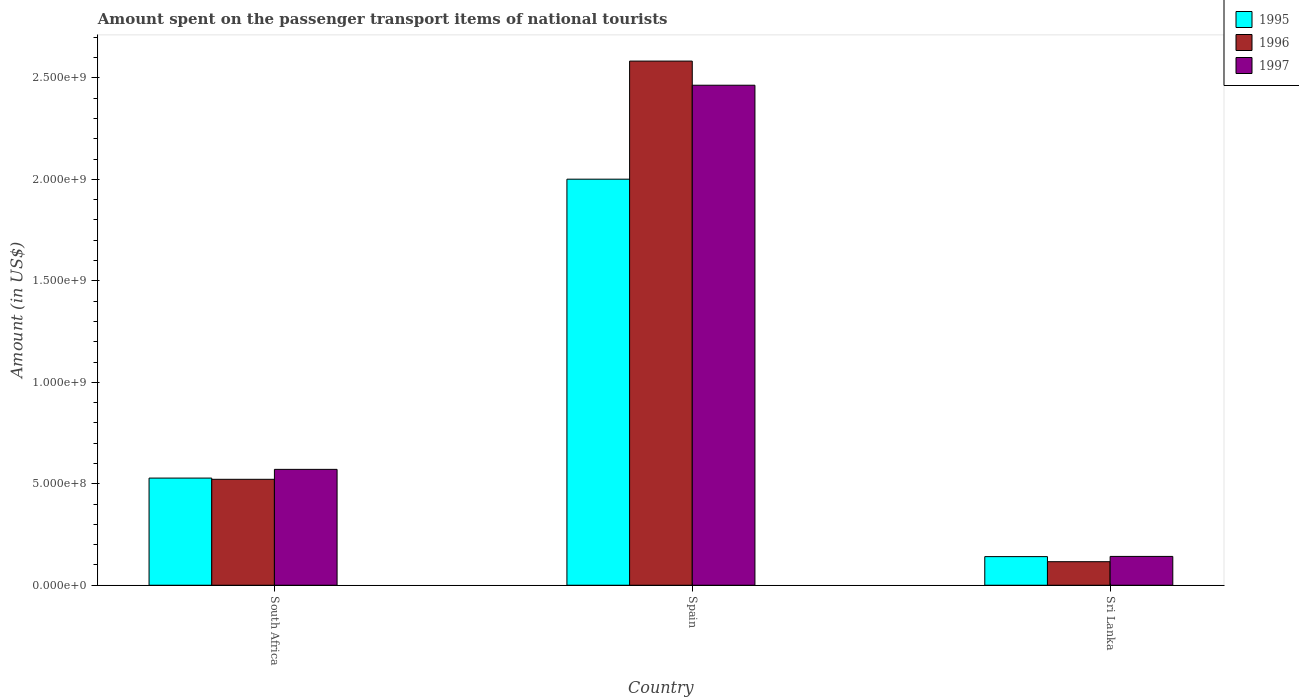How many different coloured bars are there?
Your response must be concise. 3. Are the number of bars on each tick of the X-axis equal?
Your response must be concise. Yes. How many bars are there on the 3rd tick from the left?
Ensure brevity in your answer.  3. How many bars are there on the 1st tick from the right?
Give a very brief answer. 3. What is the label of the 1st group of bars from the left?
Make the answer very short. South Africa. In how many cases, is the number of bars for a given country not equal to the number of legend labels?
Your answer should be very brief. 0. What is the amount spent on the passenger transport items of national tourists in 1997 in Sri Lanka?
Your answer should be very brief. 1.42e+08. Across all countries, what is the maximum amount spent on the passenger transport items of national tourists in 1995?
Your response must be concise. 2.00e+09. Across all countries, what is the minimum amount spent on the passenger transport items of national tourists in 1996?
Your answer should be compact. 1.16e+08. In which country was the amount spent on the passenger transport items of national tourists in 1996 minimum?
Provide a succinct answer. Sri Lanka. What is the total amount spent on the passenger transport items of national tourists in 1996 in the graph?
Your response must be concise. 3.22e+09. What is the difference between the amount spent on the passenger transport items of national tourists in 1995 in South Africa and that in Sri Lanka?
Offer a very short reply. 3.87e+08. What is the difference between the amount spent on the passenger transport items of national tourists in 1997 in Sri Lanka and the amount spent on the passenger transport items of national tourists in 1995 in South Africa?
Offer a terse response. -3.86e+08. What is the average amount spent on the passenger transport items of national tourists in 1997 per country?
Give a very brief answer. 1.06e+09. What is the difference between the amount spent on the passenger transport items of national tourists of/in 1996 and amount spent on the passenger transport items of national tourists of/in 1995 in Sri Lanka?
Ensure brevity in your answer.  -2.50e+07. Is the amount spent on the passenger transport items of national tourists in 1996 in South Africa less than that in Spain?
Your answer should be very brief. Yes. What is the difference between the highest and the second highest amount spent on the passenger transport items of national tourists in 1995?
Make the answer very short. 1.47e+09. What is the difference between the highest and the lowest amount spent on the passenger transport items of national tourists in 1997?
Offer a terse response. 2.32e+09. What does the 3rd bar from the right in Sri Lanka represents?
Your answer should be compact. 1995. Is it the case that in every country, the sum of the amount spent on the passenger transport items of national tourists in 1996 and amount spent on the passenger transport items of national tourists in 1995 is greater than the amount spent on the passenger transport items of national tourists in 1997?
Provide a succinct answer. Yes. How many bars are there?
Make the answer very short. 9. Are all the bars in the graph horizontal?
Offer a very short reply. No. How many legend labels are there?
Your answer should be very brief. 3. How are the legend labels stacked?
Make the answer very short. Vertical. What is the title of the graph?
Offer a very short reply. Amount spent on the passenger transport items of national tourists. Does "1972" appear as one of the legend labels in the graph?
Provide a short and direct response. No. What is the label or title of the Y-axis?
Provide a succinct answer. Amount (in US$). What is the Amount (in US$) of 1995 in South Africa?
Your response must be concise. 5.28e+08. What is the Amount (in US$) in 1996 in South Africa?
Provide a succinct answer. 5.22e+08. What is the Amount (in US$) of 1997 in South Africa?
Provide a succinct answer. 5.71e+08. What is the Amount (in US$) in 1995 in Spain?
Your answer should be very brief. 2.00e+09. What is the Amount (in US$) of 1996 in Spain?
Make the answer very short. 2.58e+09. What is the Amount (in US$) in 1997 in Spain?
Your answer should be very brief. 2.46e+09. What is the Amount (in US$) of 1995 in Sri Lanka?
Your answer should be compact. 1.41e+08. What is the Amount (in US$) of 1996 in Sri Lanka?
Offer a terse response. 1.16e+08. What is the Amount (in US$) in 1997 in Sri Lanka?
Your response must be concise. 1.42e+08. Across all countries, what is the maximum Amount (in US$) in 1995?
Your answer should be compact. 2.00e+09. Across all countries, what is the maximum Amount (in US$) in 1996?
Provide a short and direct response. 2.58e+09. Across all countries, what is the maximum Amount (in US$) in 1997?
Offer a terse response. 2.46e+09. Across all countries, what is the minimum Amount (in US$) in 1995?
Your answer should be very brief. 1.41e+08. Across all countries, what is the minimum Amount (in US$) of 1996?
Make the answer very short. 1.16e+08. Across all countries, what is the minimum Amount (in US$) of 1997?
Keep it short and to the point. 1.42e+08. What is the total Amount (in US$) of 1995 in the graph?
Keep it short and to the point. 2.67e+09. What is the total Amount (in US$) of 1996 in the graph?
Ensure brevity in your answer.  3.22e+09. What is the total Amount (in US$) in 1997 in the graph?
Offer a very short reply. 3.18e+09. What is the difference between the Amount (in US$) in 1995 in South Africa and that in Spain?
Offer a terse response. -1.47e+09. What is the difference between the Amount (in US$) of 1996 in South Africa and that in Spain?
Your answer should be compact. -2.06e+09. What is the difference between the Amount (in US$) of 1997 in South Africa and that in Spain?
Ensure brevity in your answer.  -1.89e+09. What is the difference between the Amount (in US$) of 1995 in South Africa and that in Sri Lanka?
Provide a succinct answer. 3.87e+08. What is the difference between the Amount (in US$) of 1996 in South Africa and that in Sri Lanka?
Offer a very short reply. 4.06e+08. What is the difference between the Amount (in US$) of 1997 in South Africa and that in Sri Lanka?
Offer a terse response. 4.29e+08. What is the difference between the Amount (in US$) in 1995 in Spain and that in Sri Lanka?
Your answer should be compact. 1.86e+09. What is the difference between the Amount (in US$) of 1996 in Spain and that in Sri Lanka?
Ensure brevity in your answer.  2.47e+09. What is the difference between the Amount (in US$) in 1997 in Spain and that in Sri Lanka?
Provide a short and direct response. 2.32e+09. What is the difference between the Amount (in US$) in 1995 in South Africa and the Amount (in US$) in 1996 in Spain?
Provide a succinct answer. -2.06e+09. What is the difference between the Amount (in US$) in 1995 in South Africa and the Amount (in US$) in 1997 in Spain?
Provide a short and direct response. -1.94e+09. What is the difference between the Amount (in US$) in 1996 in South Africa and the Amount (in US$) in 1997 in Spain?
Offer a very short reply. -1.94e+09. What is the difference between the Amount (in US$) of 1995 in South Africa and the Amount (in US$) of 1996 in Sri Lanka?
Provide a succinct answer. 4.12e+08. What is the difference between the Amount (in US$) of 1995 in South Africa and the Amount (in US$) of 1997 in Sri Lanka?
Keep it short and to the point. 3.86e+08. What is the difference between the Amount (in US$) in 1996 in South Africa and the Amount (in US$) in 1997 in Sri Lanka?
Provide a succinct answer. 3.80e+08. What is the difference between the Amount (in US$) of 1995 in Spain and the Amount (in US$) of 1996 in Sri Lanka?
Give a very brief answer. 1.88e+09. What is the difference between the Amount (in US$) of 1995 in Spain and the Amount (in US$) of 1997 in Sri Lanka?
Give a very brief answer. 1.86e+09. What is the difference between the Amount (in US$) in 1996 in Spain and the Amount (in US$) in 1997 in Sri Lanka?
Give a very brief answer. 2.44e+09. What is the average Amount (in US$) of 1995 per country?
Offer a very short reply. 8.90e+08. What is the average Amount (in US$) of 1996 per country?
Offer a very short reply. 1.07e+09. What is the average Amount (in US$) of 1997 per country?
Your answer should be compact. 1.06e+09. What is the difference between the Amount (in US$) in 1995 and Amount (in US$) in 1996 in South Africa?
Make the answer very short. 6.00e+06. What is the difference between the Amount (in US$) in 1995 and Amount (in US$) in 1997 in South Africa?
Give a very brief answer. -4.30e+07. What is the difference between the Amount (in US$) of 1996 and Amount (in US$) of 1997 in South Africa?
Give a very brief answer. -4.90e+07. What is the difference between the Amount (in US$) in 1995 and Amount (in US$) in 1996 in Spain?
Make the answer very short. -5.82e+08. What is the difference between the Amount (in US$) in 1995 and Amount (in US$) in 1997 in Spain?
Offer a very short reply. -4.63e+08. What is the difference between the Amount (in US$) of 1996 and Amount (in US$) of 1997 in Spain?
Provide a succinct answer. 1.19e+08. What is the difference between the Amount (in US$) in 1995 and Amount (in US$) in 1996 in Sri Lanka?
Your answer should be very brief. 2.50e+07. What is the difference between the Amount (in US$) of 1995 and Amount (in US$) of 1997 in Sri Lanka?
Offer a terse response. -1.00e+06. What is the difference between the Amount (in US$) in 1996 and Amount (in US$) in 1997 in Sri Lanka?
Provide a short and direct response. -2.60e+07. What is the ratio of the Amount (in US$) of 1995 in South Africa to that in Spain?
Ensure brevity in your answer.  0.26. What is the ratio of the Amount (in US$) in 1996 in South Africa to that in Spain?
Your answer should be very brief. 0.2. What is the ratio of the Amount (in US$) in 1997 in South Africa to that in Spain?
Ensure brevity in your answer.  0.23. What is the ratio of the Amount (in US$) in 1995 in South Africa to that in Sri Lanka?
Ensure brevity in your answer.  3.74. What is the ratio of the Amount (in US$) of 1997 in South Africa to that in Sri Lanka?
Your response must be concise. 4.02. What is the ratio of the Amount (in US$) in 1995 in Spain to that in Sri Lanka?
Offer a very short reply. 14.19. What is the ratio of the Amount (in US$) in 1996 in Spain to that in Sri Lanka?
Offer a very short reply. 22.27. What is the ratio of the Amount (in US$) in 1997 in Spain to that in Sri Lanka?
Your answer should be very brief. 17.35. What is the difference between the highest and the second highest Amount (in US$) of 1995?
Make the answer very short. 1.47e+09. What is the difference between the highest and the second highest Amount (in US$) of 1996?
Keep it short and to the point. 2.06e+09. What is the difference between the highest and the second highest Amount (in US$) of 1997?
Your answer should be very brief. 1.89e+09. What is the difference between the highest and the lowest Amount (in US$) of 1995?
Provide a succinct answer. 1.86e+09. What is the difference between the highest and the lowest Amount (in US$) in 1996?
Your response must be concise. 2.47e+09. What is the difference between the highest and the lowest Amount (in US$) in 1997?
Provide a short and direct response. 2.32e+09. 